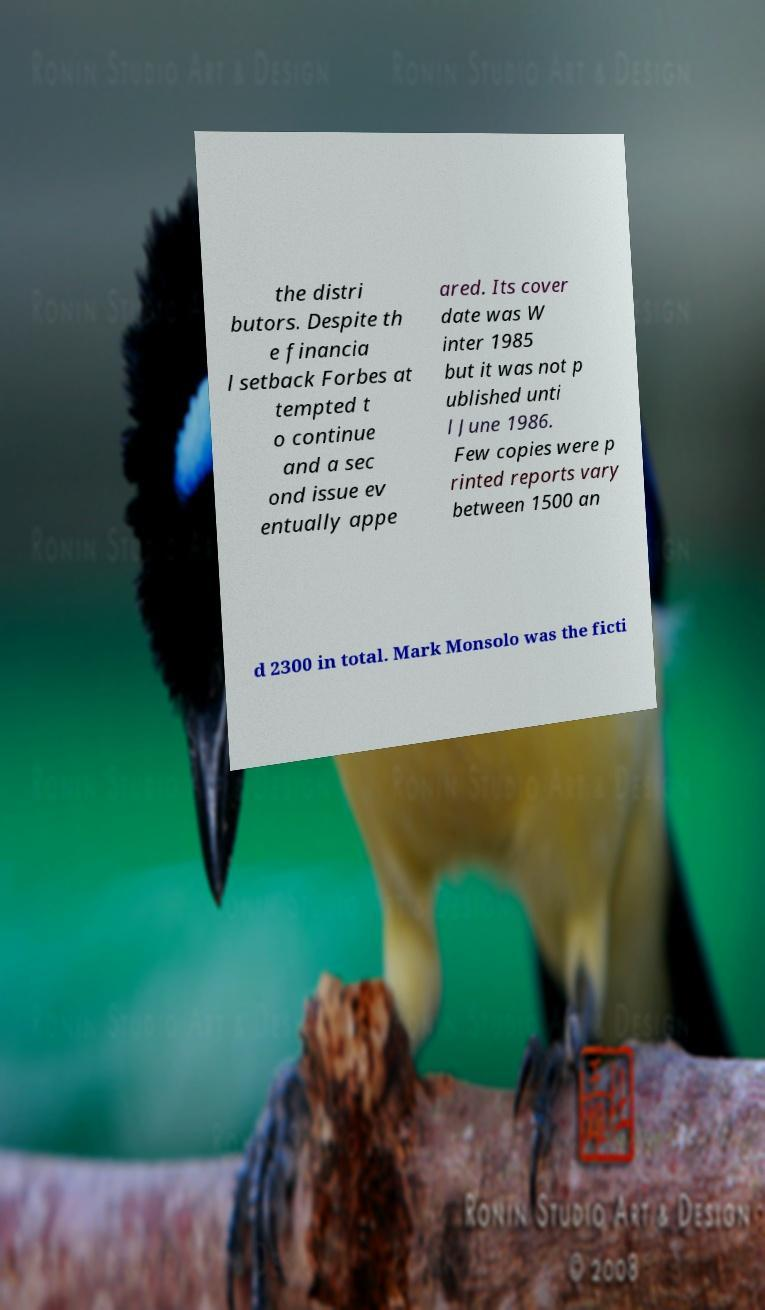Please identify and transcribe the text found in this image. the distri butors. Despite th e financia l setback Forbes at tempted t o continue and a sec ond issue ev entually appe ared. Its cover date was W inter 1985 but it was not p ublished unti l June 1986. Few copies were p rinted reports vary between 1500 an d 2300 in total. Mark Monsolo was the ficti 